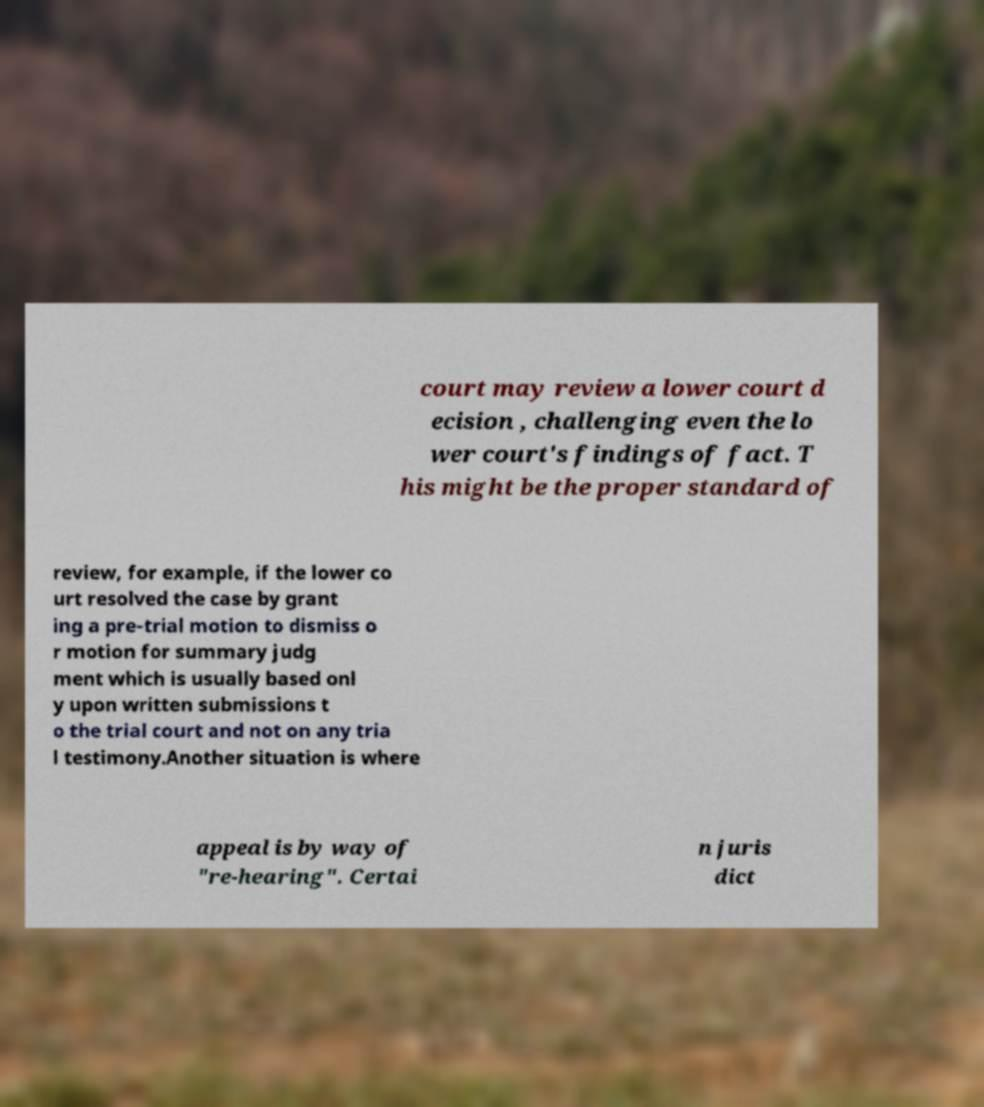Can you accurately transcribe the text from the provided image for me? court may review a lower court d ecision , challenging even the lo wer court's findings of fact. T his might be the proper standard of review, for example, if the lower co urt resolved the case by grant ing a pre-trial motion to dismiss o r motion for summary judg ment which is usually based onl y upon written submissions t o the trial court and not on any tria l testimony.Another situation is where appeal is by way of "re-hearing". Certai n juris dict 